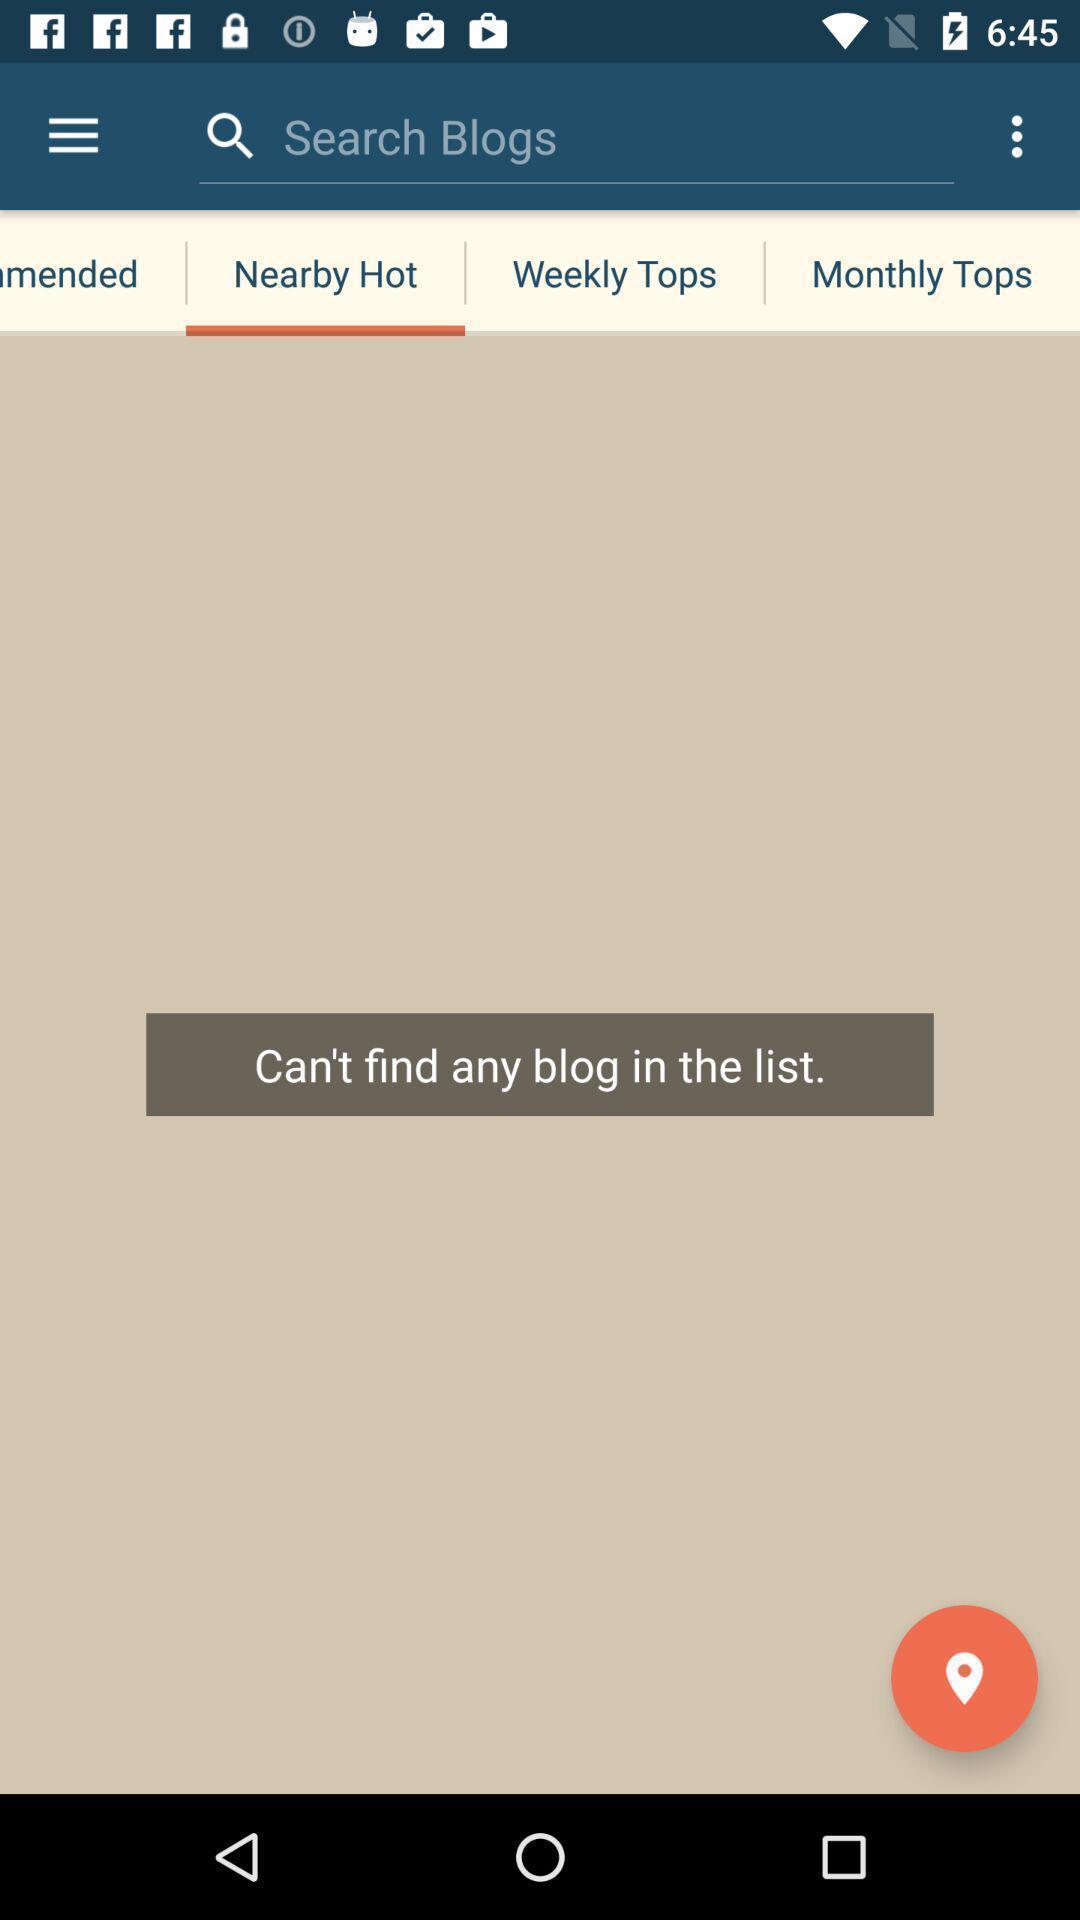Summarize the information in this screenshot. Search page shows ca n't find any blog in the list. 